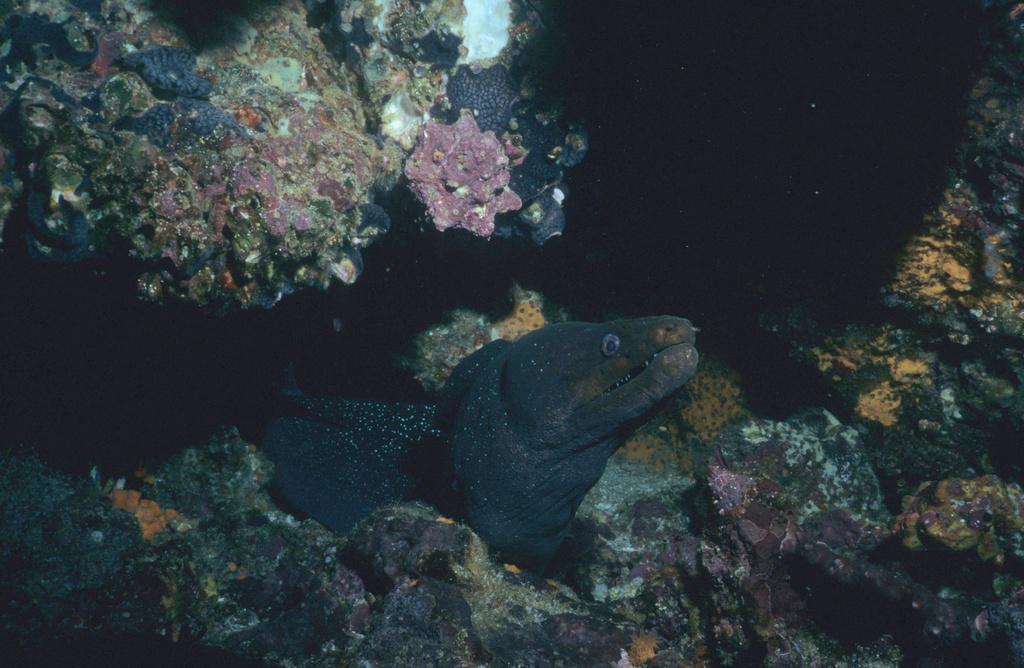Please provide a concise description of this image. In this image there is a fish under the water. Around the fish there is a coral reef. 